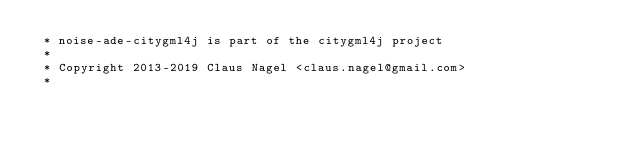Convert code to text. <code><loc_0><loc_0><loc_500><loc_500><_Java_> * noise-ade-citygml4j is part of the citygml4j project
 *
 * Copyright 2013-2019 Claus Nagel <claus.nagel@gmail.com>
 *</code> 